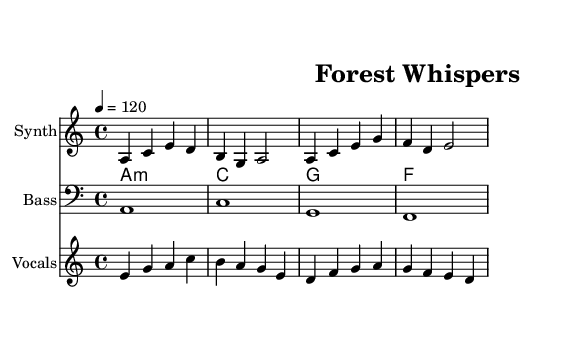What is the key signature of this music? The key signature is A minor, which has no sharps or flats.
Answer: A minor What is the time signature of this music? The time signature is found at the beginning of the score. It indicates that there are four beats in each measure.
Answer: 4/4 What is the tempo marking in this piece? The tempo marking indicates the speed of the music, noted at the beginning of the score as "4 = 120". This means there are 120 beats per minute.
Answer: 120 How many measures are in the vocal melody? To determine the number of measures, I counted the vertical lines (bar lines) in the vocal melody. Each bar line represents the end of a measure.
Answer: 4 What instrument is represented by the first staff? The first staff is labeled as "Synth," indicating that it is for a synthesizer.
Answer: Synth What type of vocal technique is used in the lyrics? The lyrics illustrate soft, gentle expressions, reflecting the characteristics of ambient music, often using whispering to convey emotions.
Answer: Whispering What chord is played along with the first measure of melody? The first measure of melody corresponds to the chord labeled as "A minor" in the chord names section, indicating the harmony used during that measure.
Answer: A minor 